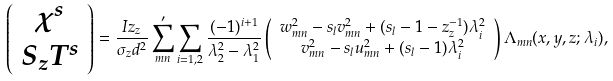Convert formula to latex. <formula><loc_0><loc_0><loc_500><loc_500>\left ( \begin{array} { c } \chi ^ { s } \\ S _ { z } T ^ { s } \end{array} \right ) & = \frac { I z _ { z } } { \sigma _ { z } d ^ { 2 } } \sum _ { m n } ^ { \prime } \sum _ { i = 1 , 2 } \frac { ( - 1 ) ^ { i + 1 } } { \lambda _ { 2 } ^ { 2 } - \lambda _ { 1 } ^ { 2 } } \left ( \begin{array} { c } w _ { m n } ^ { 2 } - s _ { l } v _ { m n } ^ { 2 } + ( s _ { l } - 1 - z _ { z } ^ { - 1 } ) \lambda _ { i } ^ { 2 } \\ v _ { m n } ^ { 2 } - s _ { l } u _ { m n } ^ { 2 } + ( s _ { l } - 1 ) \lambda _ { i } ^ { 2 } \end{array} \right ) \Lambda _ { m n } ( x , y , z ; \lambda _ { i } ) ,</formula> 